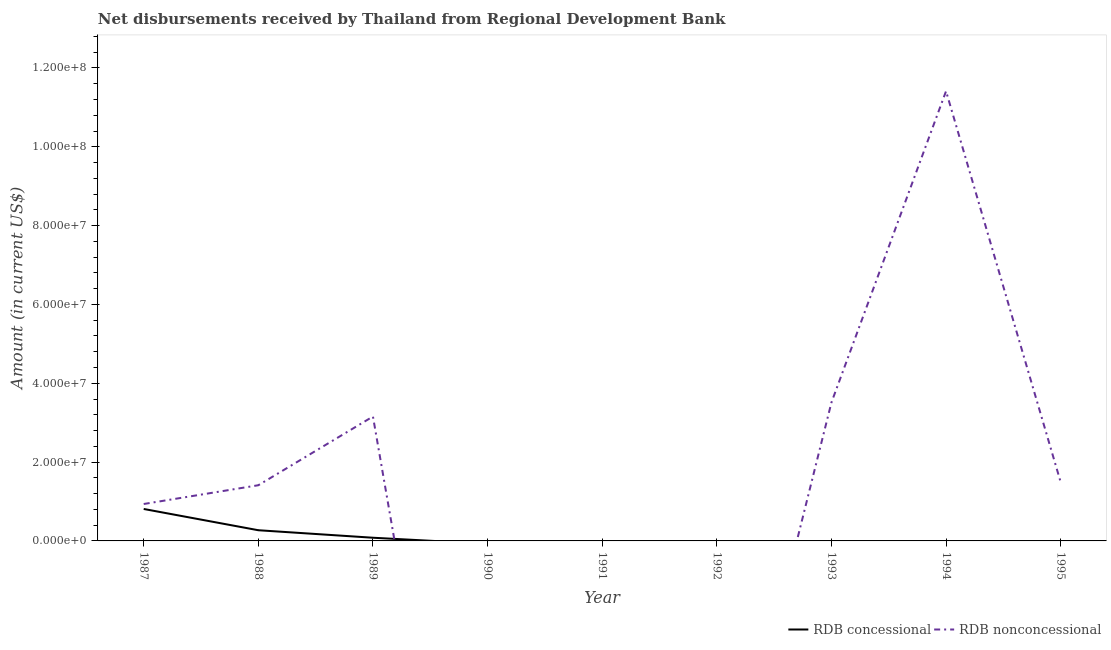How many different coloured lines are there?
Keep it short and to the point. 2. Does the line corresponding to net concessional disbursements from rdb intersect with the line corresponding to net non concessional disbursements from rdb?
Offer a terse response. Yes. Is the number of lines equal to the number of legend labels?
Provide a short and direct response. No. Across all years, what is the maximum net concessional disbursements from rdb?
Keep it short and to the point. 8.10e+06. Across all years, what is the minimum net concessional disbursements from rdb?
Provide a short and direct response. 0. In which year was the net non concessional disbursements from rdb maximum?
Keep it short and to the point. 1994. What is the total net concessional disbursements from rdb in the graph?
Give a very brief answer. 1.16e+07. What is the difference between the net concessional disbursements from rdb in 1988 and that in 1989?
Keep it short and to the point. 1.90e+06. What is the average net non concessional disbursements from rdb per year?
Provide a short and direct response. 2.44e+07. In the year 1989, what is the difference between the net concessional disbursements from rdb and net non concessional disbursements from rdb?
Give a very brief answer. -3.08e+07. What is the ratio of the net non concessional disbursements from rdb in 1988 to that in 1995?
Provide a short and direct response. 0.95. What is the difference between the highest and the second highest net non concessional disbursements from rdb?
Give a very brief answer. 7.90e+07. What is the difference between the highest and the lowest net concessional disbursements from rdb?
Make the answer very short. 8.10e+06. Is the net concessional disbursements from rdb strictly greater than the net non concessional disbursements from rdb over the years?
Your answer should be compact. No. Does the graph contain grids?
Make the answer very short. No. Where does the legend appear in the graph?
Ensure brevity in your answer.  Bottom right. How many legend labels are there?
Provide a short and direct response. 2. What is the title of the graph?
Offer a very short reply. Net disbursements received by Thailand from Regional Development Bank. Does "Broad money growth" appear as one of the legend labels in the graph?
Make the answer very short. No. What is the label or title of the X-axis?
Your response must be concise. Year. What is the label or title of the Y-axis?
Provide a succinct answer. Amount (in current US$). What is the Amount (in current US$) of RDB concessional in 1987?
Ensure brevity in your answer.  8.10e+06. What is the Amount (in current US$) in RDB nonconcessional in 1987?
Offer a terse response. 9.37e+06. What is the Amount (in current US$) in RDB concessional in 1988?
Offer a very short reply. 2.71e+06. What is the Amount (in current US$) in RDB nonconcessional in 1988?
Provide a succinct answer. 1.41e+07. What is the Amount (in current US$) in RDB concessional in 1989?
Keep it short and to the point. 8.09e+05. What is the Amount (in current US$) in RDB nonconcessional in 1989?
Give a very brief answer. 3.16e+07. What is the Amount (in current US$) of RDB concessional in 1990?
Offer a terse response. 0. What is the Amount (in current US$) in RDB nonconcessional in 1990?
Make the answer very short. 0. What is the Amount (in current US$) in RDB nonconcessional in 1991?
Keep it short and to the point. 0. What is the Amount (in current US$) of RDB concessional in 1992?
Offer a very short reply. 0. What is the Amount (in current US$) of RDB nonconcessional in 1992?
Offer a very short reply. 0. What is the Amount (in current US$) of RDB concessional in 1993?
Offer a terse response. 0. What is the Amount (in current US$) in RDB nonconcessional in 1993?
Your answer should be very brief. 3.51e+07. What is the Amount (in current US$) of RDB concessional in 1994?
Keep it short and to the point. 0. What is the Amount (in current US$) in RDB nonconcessional in 1994?
Provide a succinct answer. 1.14e+08. What is the Amount (in current US$) of RDB nonconcessional in 1995?
Keep it short and to the point. 1.49e+07. Across all years, what is the maximum Amount (in current US$) in RDB concessional?
Make the answer very short. 8.10e+06. Across all years, what is the maximum Amount (in current US$) in RDB nonconcessional?
Your response must be concise. 1.14e+08. Across all years, what is the minimum Amount (in current US$) of RDB concessional?
Your answer should be very brief. 0. Across all years, what is the minimum Amount (in current US$) in RDB nonconcessional?
Your answer should be very brief. 0. What is the total Amount (in current US$) of RDB concessional in the graph?
Offer a terse response. 1.16e+07. What is the total Amount (in current US$) of RDB nonconcessional in the graph?
Make the answer very short. 2.19e+08. What is the difference between the Amount (in current US$) in RDB concessional in 1987 and that in 1988?
Make the answer very short. 5.39e+06. What is the difference between the Amount (in current US$) of RDB nonconcessional in 1987 and that in 1988?
Provide a short and direct response. -4.76e+06. What is the difference between the Amount (in current US$) in RDB concessional in 1987 and that in 1989?
Your answer should be very brief. 7.30e+06. What is the difference between the Amount (in current US$) of RDB nonconcessional in 1987 and that in 1989?
Offer a terse response. -2.22e+07. What is the difference between the Amount (in current US$) of RDB nonconcessional in 1987 and that in 1993?
Offer a very short reply. -2.57e+07. What is the difference between the Amount (in current US$) in RDB nonconcessional in 1987 and that in 1994?
Make the answer very short. -1.05e+08. What is the difference between the Amount (in current US$) of RDB nonconcessional in 1987 and that in 1995?
Offer a terse response. -5.56e+06. What is the difference between the Amount (in current US$) in RDB concessional in 1988 and that in 1989?
Your response must be concise. 1.90e+06. What is the difference between the Amount (in current US$) of RDB nonconcessional in 1988 and that in 1989?
Keep it short and to the point. -1.74e+07. What is the difference between the Amount (in current US$) of RDB nonconcessional in 1988 and that in 1993?
Your answer should be compact. -2.10e+07. What is the difference between the Amount (in current US$) of RDB nonconcessional in 1988 and that in 1994?
Keep it short and to the point. -1.00e+08. What is the difference between the Amount (in current US$) in RDB nonconcessional in 1988 and that in 1995?
Provide a succinct answer. -8.00e+05. What is the difference between the Amount (in current US$) of RDB nonconcessional in 1989 and that in 1993?
Your answer should be very brief. -3.54e+06. What is the difference between the Amount (in current US$) in RDB nonconcessional in 1989 and that in 1994?
Offer a terse response. -8.25e+07. What is the difference between the Amount (in current US$) of RDB nonconcessional in 1989 and that in 1995?
Provide a succinct answer. 1.66e+07. What is the difference between the Amount (in current US$) in RDB nonconcessional in 1993 and that in 1994?
Your response must be concise. -7.90e+07. What is the difference between the Amount (in current US$) in RDB nonconcessional in 1993 and that in 1995?
Provide a succinct answer. 2.02e+07. What is the difference between the Amount (in current US$) in RDB nonconcessional in 1994 and that in 1995?
Give a very brief answer. 9.92e+07. What is the difference between the Amount (in current US$) in RDB concessional in 1987 and the Amount (in current US$) in RDB nonconcessional in 1988?
Offer a very short reply. -6.02e+06. What is the difference between the Amount (in current US$) of RDB concessional in 1987 and the Amount (in current US$) of RDB nonconcessional in 1989?
Make the answer very short. -2.35e+07. What is the difference between the Amount (in current US$) of RDB concessional in 1987 and the Amount (in current US$) of RDB nonconcessional in 1993?
Your answer should be very brief. -2.70e+07. What is the difference between the Amount (in current US$) of RDB concessional in 1987 and the Amount (in current US$) of RDB nonconcessional in 1994?
Keep it short and to the point. -1.06e+08. What is the difference between the Amount (in current US$) of RDB concessional in 1987 and the Amount (in current US$) of RDB nonconcessional in 1995?
Your answer should be compact. -6.82e+06. What is the difference between the Amount (in current US$) in RDB concessional in 1988 and the Amount (in current US$) in RDB nonconcessional in 1989?
Your response must be concise. -2.89e+07. What is the difference between the Amount (in current US$) of RDB concessional in 1988 and the Amount (in current US$) of RDB nonconcessional in 1993?
Give a very brief answer. -3.24e+07. What is the difference between the Amount (in current US$) in RDB concessional in 1988 and the Amount (in current US$) in RDB nonconcessional in 1994?
Provide a short and direct response. -1.11e+08. What is the difference between the Amount (in current US$) in RDB concessional in 1988 and the Amount (in current US$) in RDB nonconcessional in 1995?
Your answer should be compact. -1.22e+07. What is the difference between the Amount (in current US$) in RDB concessional in 1989 and the Amount (in current US$) in RDB nonconcessional in 1993?
Keep it short and to the point. -3.43e+07. What is the difference between the Amount (in current US$) in RDB concessional in 1989 and the Amount (in current US$) in RDB nonconcessional in 1994?
Offer a terse response. -1.13e+08. What is the difference between the Amount (in current US$) of RDB concessional in 1989 and the Amount (in current US$) of RDB nonconcessional in 1995?
Provide a short and direct response. -1.41e+07. What is the average Amount (in current US$) of RDB concessional per year?
Your response must be concise. 1.29e+06. What is the average Amount (in current US$) in RDB nonconcessional per year?
Your answer should be very brief. 2.44e+07. In the year 1987, what is the difference between the Amount (in current US$) of RDB concessional and Amount (in current US$) of RDB nonconcessional?
Give a very brief answer. -1.26e+06. In the year 1988, what is the difference between the Amount (in current US$) in RDB concessional and Amount (in current US$) in RDB nonconcessional?
Ensure brevity in your answer.  -1.14e+07. In the year 1989, what is the difference between the Amount (in current US$) in RDB concessional and Amount (in current US$) in RDB nonconcessional?
Give a very brief answer. -3.08e+07. What is the ratio of the Amount (in current US$) of RDB concessional in 1987 to that in 1988?
Provide a succinct answer. 2.99. What is the ratio of the Amount (in current US$) in RDB nonconcessional in 1987 to that in 1988?
Your response must be concise. 0.66. What is the ratio of the Amount (in current US$) of RDB concessional in 1987 to that in 1989?
Your answer should be compact. 10.02. What is the ratio of the Amount (in current US$) of RDB nonconcessional in 1987 to that in 1989?
Offer a terse response. 0.3. What is the ratio of the Amount (in current US$) of RDB nonconcessional in 1987 to that in 1993?
Offer a very short reply. 0.27. What is the ratio of the Amount (in current US$) in RDB nonconcessional in 1987 to that in 1994?
Make the answer very short. 0.08. What is the ratio of the Amount (in current US$) in RDB nonconcessional in 1987 to that in 1995?
Ensure brevity in your answer.  0.63. What is the ratio of the Amount (in current US$) of RDB concessional in 1988 to that in 1989?
Provide a short and direct response. 3.35. What is the ratio of the Amount (in current US$) in RDB nonconcessional in 1988 to that in 1989?
Keep it short and to the point. 0.45. What is the ratio of the Amount (in current US$) in RDB nonconcessional in 1988 to that in 1993?
Provide a succinct answer. 0.4. What is the ratio of the Amount (in current US$) of RDB nonconcessional in 1988 to that in 1994?
Offer a terse response. 0.12. What is the ratio of the Amount (in current US$) of RDB nonconcessional in 1988 to that in 1995?
Offer a terse response. 0.95. What is the ratio of the Amount (in current US$) of RDB nonconcessional in 1989 to that in 1993?
Offer a terse response. 0.9. What is the ratio of the Amount (in current US$) in RDB nonconcessional in 1989 to that in 1994?
Make the answer very short. 0.28. What is the ratio of the Amount (in current US$) in RDB nonconcessional in 1989 to that in 1995?
Your answer should be very brief. 2.11. What is the ratio of the Amount (in current US$) in RDB nonconcessional in 1993 to that in 1994?
Your response must be concise. 0.31. What is the ratio of the Amount (in current US$) in RDB nonconcessional in 1993 to that in 1995?
Offer a terse response. 2.35. What is the ratio of the Amount (in current US$) in RDB nonconcessional in 1994 to that in 1995?
Keep it short and to the point. 7.64. What is the difference between the highest and the second highest Amount (in current US$) in RDB concessional?
Give a very brief answer. 5.39e+06. What is the difference between the highest and the second highest Amount (in current US$) in RDB nonconcessional?
Provide a short and direct response. 7.90e+07. What is the difference between the highest and the lowest Amount (in current US$) of RDB concessional?
Your answer should be very brief. 8.10e+06. What is the difference between the highest and the lowest Amount (in current US$) of RDB nonconcessional?
Your answer should be very brief. 1.14e+08. 